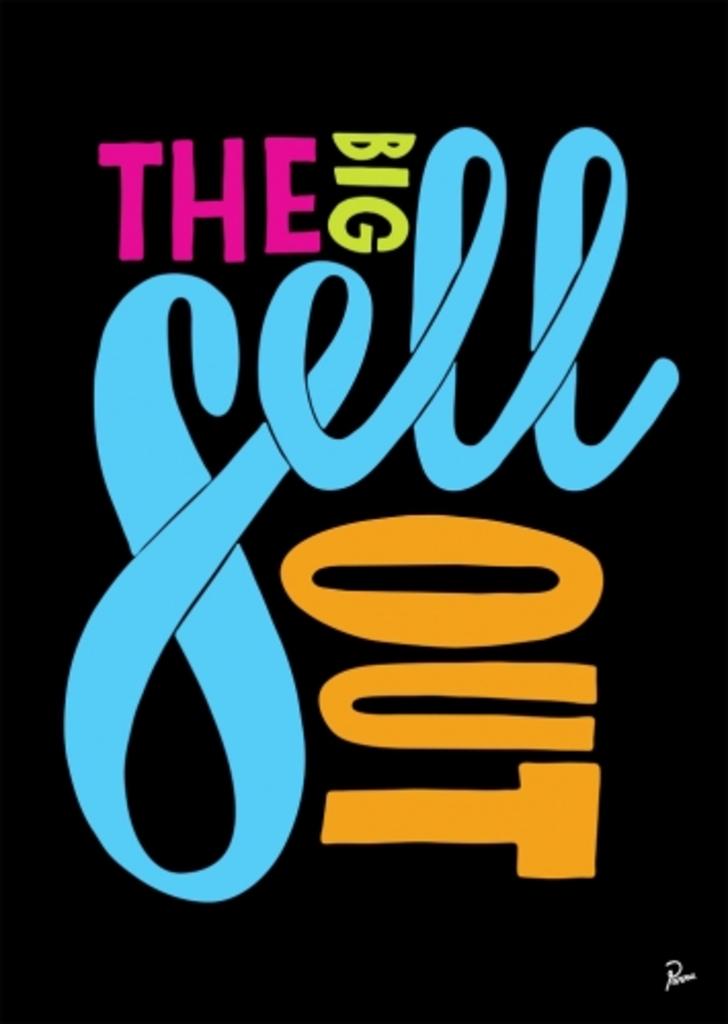What word is blue on this drawing?
Give a very brief answer. Sell. 